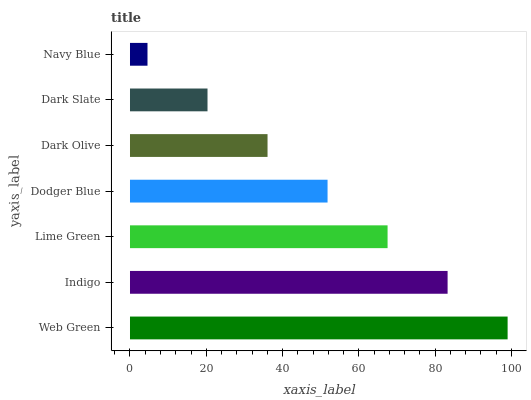Is Navy Blue the minimum?
Answer yes or no. Yes. Is Web Green the maximum?
Answer yes or no. Yes. Is Indigo the minimum?
Answer yes or no. No. Is Indigo the maximum?
Answer yes or no. No. Is Web Green greater than Indigo?
Answer yes or no. Yes. Is Indigo less than Web Green?
Answer yes or no. Yes. Is Indigo greater than Web Green?
Answer yes or no. No. Is Web Green less than Indigo?
Answer yes or no. No. Is Dodger Blue the high median?
Answer yes or no. Yes. Is Dodger Blue the low median?
Answer yes or no. Yes. Is Web Green the high median?
Answer yes or no. No. Is Dark Slate the low median?
Answer yes or no. No. 